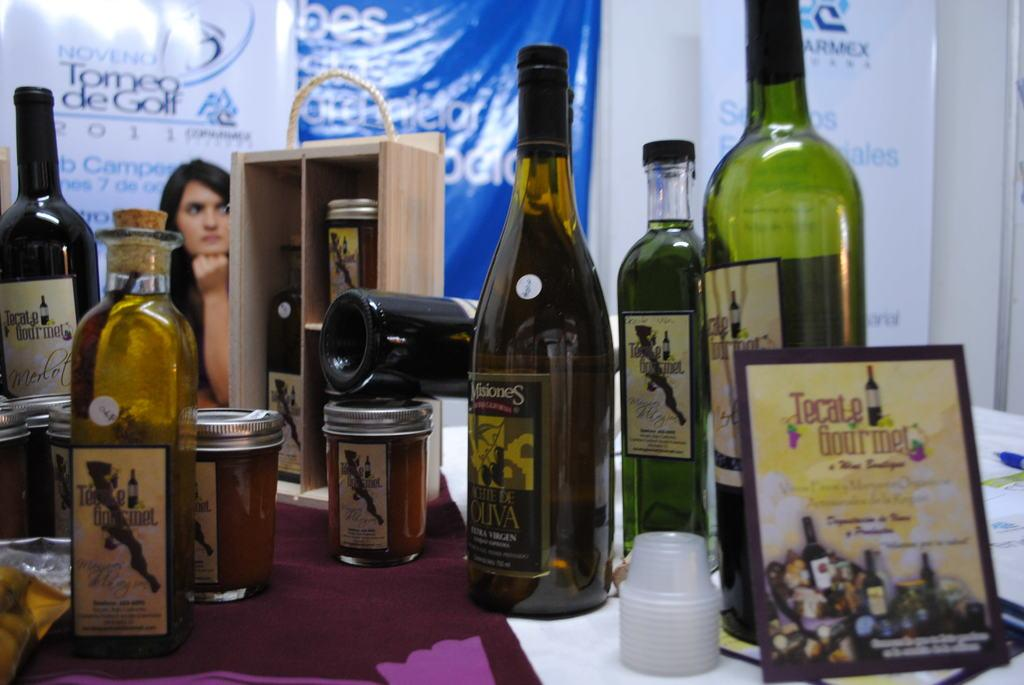<image>
Create a compact narrative representing the image presented. Various food products on a table from Tecate Gourmet. 